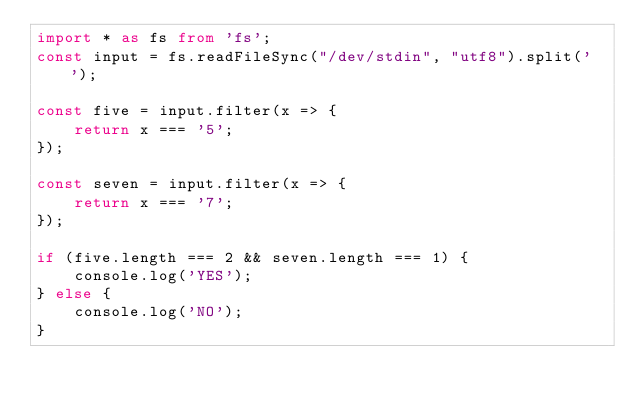<code> <loc_0><loc_0><loc_500><loc_500><_TypeScript_>import * as fs from 'fs';
const input = fs.readFileSync("/dev/stdin", "utf8").split(' ');

const five = input.filter(x => {
    return x === '5';
});

const seven = input.filter(x => {
    return x === '7';
});

if (five.length === 2 && seven.length === 1) {
    console.log('YES');
} else {
    console.log('NO');
}
</code> 